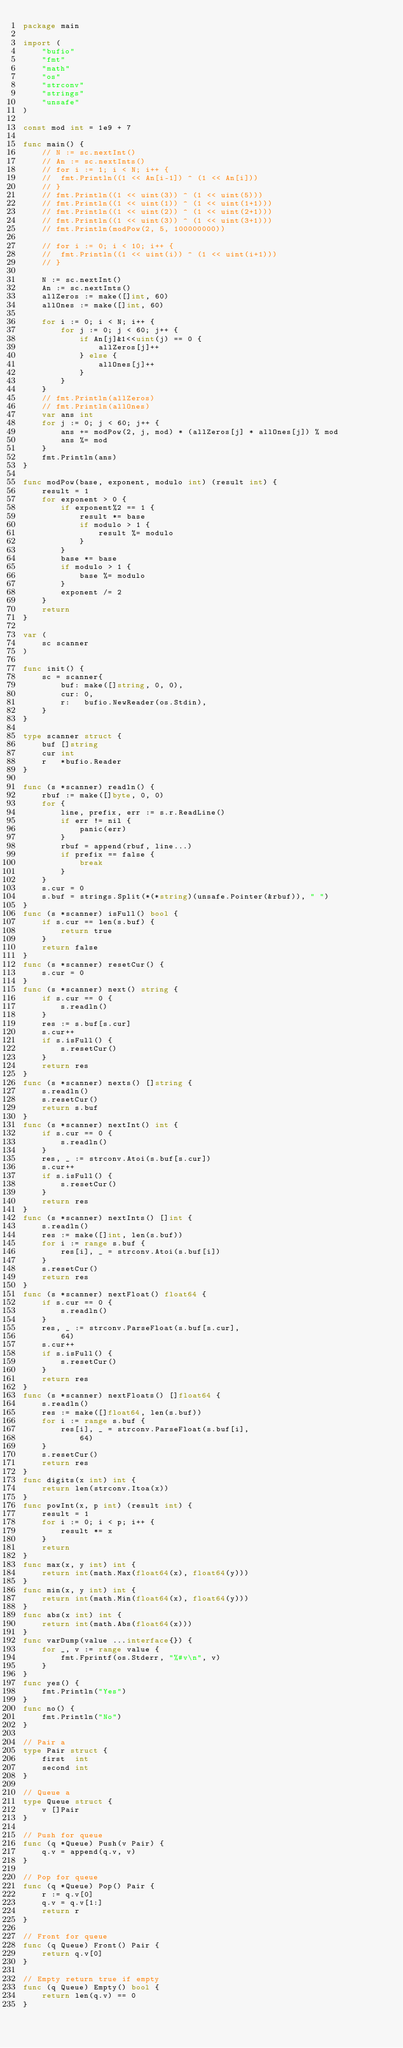<code> <loc_0><loc_0><loc_500><loc_500><_Go_>package main

import (
	"bufio"
	"fmt"
	"math"
	"os"
	"strconv"
	"strings"
	"unsafe"
)

const mod int = 1e9 + 7

func main() {
	// N := sc.nextInt()
	// An := sc.nextInts()
	// for i := 1; i < N; i++ {
	// 	fmt.Println((1 << An[i-1]) ^ (1 << An[i]))
	// }
	// fmt.Println((1 << uint(3)) ^ (1 << uint(5)))
	// fmt.Println((1 << uint(1)) ^ (1 << uint(1+1)))
	// fmt.Println((1 << uint(2)) ^ (1 << uint(2+1)))
	// fmt.Println((1 << uint(3)) ^ (1 << uint(3+1)))
	// fmt.Println(modPow(2, 5, 100000000))

	// for i := 0; i < 10; i++ {
	// 	fmt.Println((1 << uint(i)) ^ (1 << uint(i+1)))
	// }

	N := sc.nextInt()
	An := sc.nextInts()
	allZeros := make([]int, 60)
	allOnes := make([]int, 60)

	for i := 0; i < N; i++ {
		for j := 0; j < 60; j++ {
			if An[j]&1<<uint(j) == 0 {
				allZeros[j]++
			} else {
				allOnes[j]++
			}
		}
	}
	// fmt.Println(allZeros)
	// fmt.Println(allOnes)
	var ans int
	for j := 0; j < 60; j++ {
		ans += modPow(2, j, mod) * (allZeros[j] * allOnes[j]) % mod
		ans %= mod
	}
	fmt.Println(ans)
}

func modPow(base, exponent, modulo int) (result int) {
	result = 1
	for exponent > 0 {
		if exponent%2 == 1 {
			result *= base
			if modulo > 1 {
				result %= modulo
			}
		}
		base *= base
		if modulo > 1 {
			base %= modulo
		}
		exponent /= 2
	}
	return
}

var (
	sc scanner
)

func init() {
	sc = scanner{
		buf: make([]string, 0, 0),
		cur: 0,
		r:   bufio.NewReader(os.Stdin),
	}
}

type scanner struct {
	buf []string
	cur int
	r   *bufio.Reader
}

func (s *scanner) readln() {
	rbuf := make([]byte, 0, 0)
	for {
		line, prefix, err := s.r.ReadLine()
		if err != nil {
			panic(err)
		}
		rbuf = append(rbuf, line...)
		if prefix == false {
			break
		}
	}
	s.cur = 0
	s.buf = strings.Split(*(*string)(unsafe.Pointer(&rbuf)), " ")
}
func (s *scanner) isFull() bool {
	if s.cur == len(s.buf) {
		return true
	}
	return false
}
func (s *scanner) resetCur() {
	s.cur = 0
}
func (s *scanner) next() string {
	if s.cur == 0 {
		s.readln()
	}
	res := s.buf[s.cur]
	s.cur++
	if s.isFull() {
		s.resetCur()
	}
	return res
}
func (s *scanner) nexts() []string {
	s.readln()
	s.resetCur()
	return s.buf
}
func (s *scanner) nextInt() int {
	if s.cur == 0 {
		s.readln()
	}
	res, _ := strconv.Atoi(s.buf[s.cur])
	s.cur++
	if s.isFull() {
		s.resetCur()
	}
	return res
}
func (s *scanner) nextInts() []int {
	s.readln()
	res := make([]int, len(s.buf))
	for i := range s.buf {
		res[i], _ = strconv.Atoi(s.buf[i])
	}
	s.resetCur()
	return res
}
func (s *scanner) nextFloat() float64 {
	if s.cur == 0 {
		s.readln()
	}
	res, _ := strconv.ParseFloat(s.buf[s.cur],
		64)
	s.cur++
	if s.isFull() {
		s.resetCur()
	}
	return res
}
func (s *scanner) nextFloats() []float64 {
	s.readln()
	res := make([]float64, len(s.buf))
	for i := range s.buf {
		res[i], _ = strconv.ParseFloat(s.buf[i],
			64)
	}
	s.resetCur()
	return res
}
func digits(x int) int {
	return len(strconv.Itoa(x))
}
func powInt(x, p int) (result int) {
	result = 1
	for i := 0; i < p; i++ {
		result *= x
	}
	return
}
func max(x, y int) int {
	return int(math.Max(float64(x), float64(y)))
}
func min(x, y int) int {
	return int(math.Min(float64(x), float64(y)))
}
func abs(x int) int {
	return int(math.Abs(float64(x)))
}
func varDump(value ...interface{}) {
	for _, v := range value {
		fmt.Fprintf(os.Stderr, "%#v\n", v)
	}
}
func yes() {
	fmt.Println("Yes")
}
func no() {
	fmt.Println("No")
}

// Pair a
type Pair struct {
	first  int
	second int
}

// Queue a
type Queue struct {
	v []Pair
}

// Push for queue
func (q *Queue) Push(v Pair) {
	q.v = append(q.v, v)
}

// Pop for queue
func (q *Queue) Pop() Pair {
	r := q.v[0]
	q.v = q.v[1:]
	return r
}

// Front for queue
func (q Queue) Front() Pair {
	return q.v[0]
}

// Empty return true if empty
func (q Queue) Empty() bool {
	return len(q.v) == 0
}
</code> 